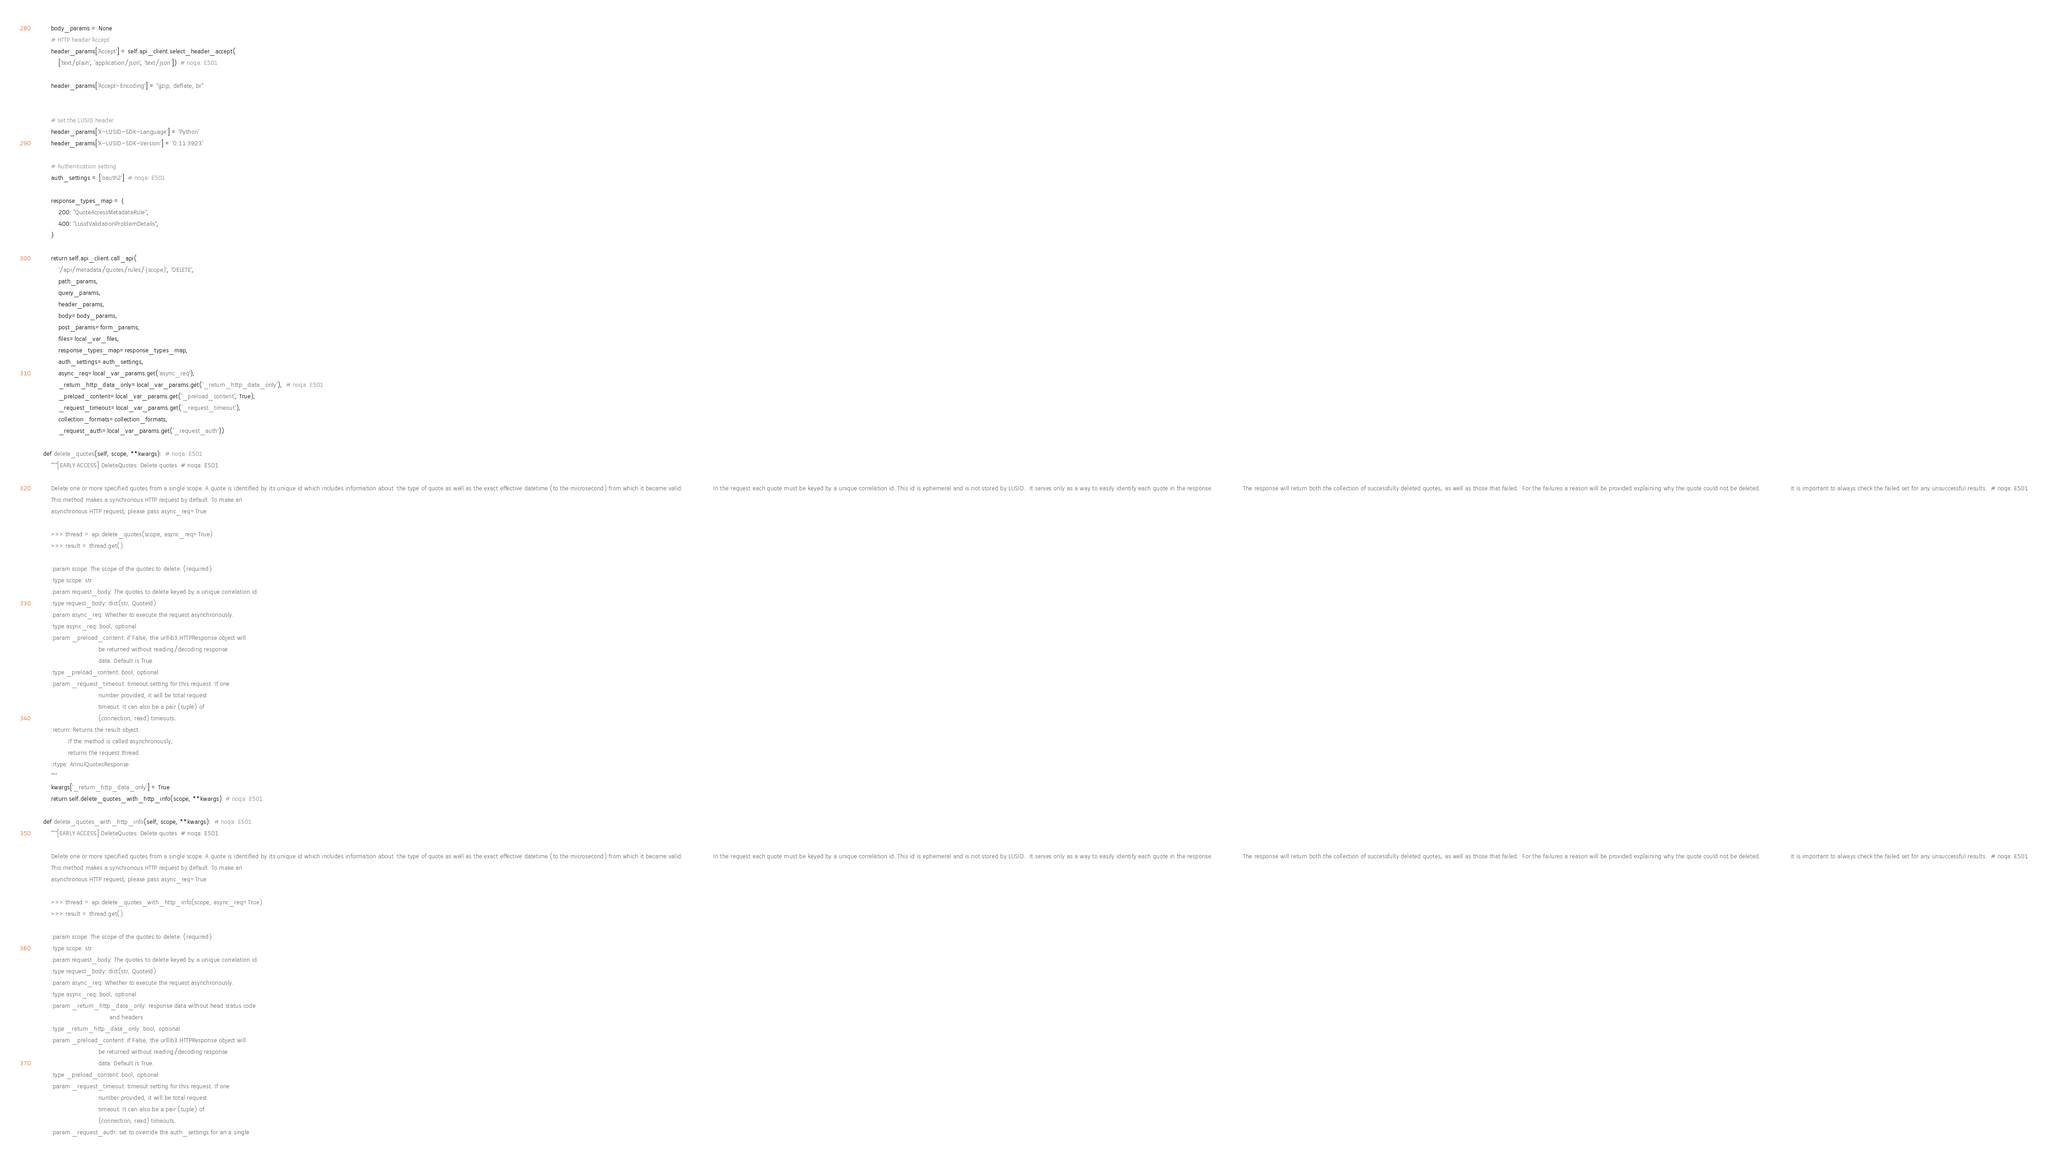<code> <loc_0><loc_0><loc_500><loc_500><_Python_>
        body_params = None
        # HTTP header `Accept`
        header_params['Accept'] = self.api_client.select_header_accept(
            ['text/plain', 'application/json', 'text/json'])  # noqa: E501

        header_params['Accept-Encoding'] = "gzip, deflate, br"


        # set the LUSID header
        header_params['X-LUSID-SDK-Language'] = 'Python'
        header_params['X-LUSID-SDK-Version'] = '0.11.3923'

        # Authentication setting
        auth_settings = ['oauth2']  # noqa: E501
        
        response_types_map = {
            200: "QuoteAccessMetadataRule",
            400: "LusidValidationProblemDetails",
        }

        return self.api_client.call_api(
            '/api/metadata/quotes/rules/{scope}', 'DELETE',
            path_params,
            query_params,
            header_params,
            body=body_params,
            post_params=form_params,
            files=local_var_files,
            response_types_map=response_types_map,
            auth_settings=auth_settings,
            async_req=local_var_params.get('async_req'),
            _return_http_data_only=local_var_params.get('_return_http_data_only'),  # noqa: E501
            _preload_content=local_var_params.get('_preload_content', True),
            _request_timeout=local_var_params.get('_request_timeout'),
            collection_formats=collection_formats,
            _request_auth=local_var_params.get('_request_auth'))

    def delete_quotes(self, scope, **kwargs):  # noqa: E501
        """[EARLY ACCESS] DeleteQuotes: Delete quotes  # noqa: E501

        Delete one or more specified quotes from a single scope. A quote is identified by its unique id which includes information about  the type of quote as well as the exact effective datetime (to the microsecond) from which it became valid.                In the request each quote must be keyed by a unique correlation id. This id is ephemeral and is not stored by LUSID.  It serves only as a way to easily identify each quote in the response.                The response will return both the collection of successfully deleted quotes, as well as those that failed.  For the failures a reason will be provided explaining why the quote could not be deleted.                It is important to always check the failed set for any unsuccessful results.  # noqa: E501
        This method makes a synchronous HTTP request by default. To make an
        asynchronous HTTP request, please pass async_req=True

        >>> thread = api.delete_quotes(scope, async_req=True)
        >>> result = thread.get()

        :param scope: The scope of the quotes to delete. (required)
        :type scope: str
        :param request_body: The quotes to delete keyed by a unique correlation id.
        :type request_body: dict(str, QuoteId)
        :param async_req: Whether to execute the request asynchronously.
        :type async_req: bool, optional
        :param _preload_content: if False, the urllib3.HTTPResponse object will
                                 be returned without reading/decoding response
                                 data. Default is True.
        :type _preload_content: bool, optional
        :param _request_timeout: timeout setting for this request. If one
                                 number provided, it will be total request
                                 timeout. It can also be a pair (tuple) of
                                 (connection, read) timeouts.
        :return: Returns the result object.
                 If the method is called asynchronously,
                 returns the request thread.
        :rtype: AnnulQuotesResponse
        """
        kwargs['_return_http_data_only'] = True
        return self.delete_quotes_with_http_info(scope, **kwargs)  # noqa: E501

    def delete_quotes_with_http_info(self, scope, **kwargs):  # noqa: E501
        """[EARLY ACCESS] DeleteQuotes: Delete quotes  # noqa: E501

        Delete one or more specified quotes from a single scope. A quote is identified by its unique id which includes information about  the type of quote as well as the exact effective datetime (to the microsecond) from which it became valid.                In the request each quote must be keyed by a unique correlation id. This id is ephemeral and is not stored by LUSID.  It serves only as a way to easily identify each quote in the response.                The response will return both the collection of successfully deleted quotes, as well as those that failed.  For the failures a reason will be provided explaining why the quote could not be deleted.                It is important to always check the failed set for any unsuccessful results.  # noqa: E501
        This method makes a synchronous HTTP request by default. To make an
        asynchronous HTTP request, please pass async_req=True

        >>> thread = api.delete_quotes_with_http_info(scope, async_req=True)
        >>> result = thread.get()

        :param scope: The scope of the quotes to delete. (required)
        :type scope: str
        :param request_body: The quotes to delete keyed by a unique correlation id.
        :type request_body: dict(str, QuoteId)
        :param async_req: Whether to execute the request asynchronously.
        :type async_req: bool, optional
        :param _return_http_data_only: response data without head status code
                                       and headers
        :type _return_http_data_only: bool, optional
        :param _preload_content: if False, the urllib3.HTTPResponse object will
                                 be returned without reading/decoding response
                                 data. Default is True.
        :type _preload_content: bool, optional
        :param _request_timeout: timeout setting for this request. If one
                                 number provided, it will be total request
                                 timeout. It can also be a pair (tuple) of
                                 (connection, read) timeouts.
        :param _request_auth: set to override the auth_settings for an a single</code> 